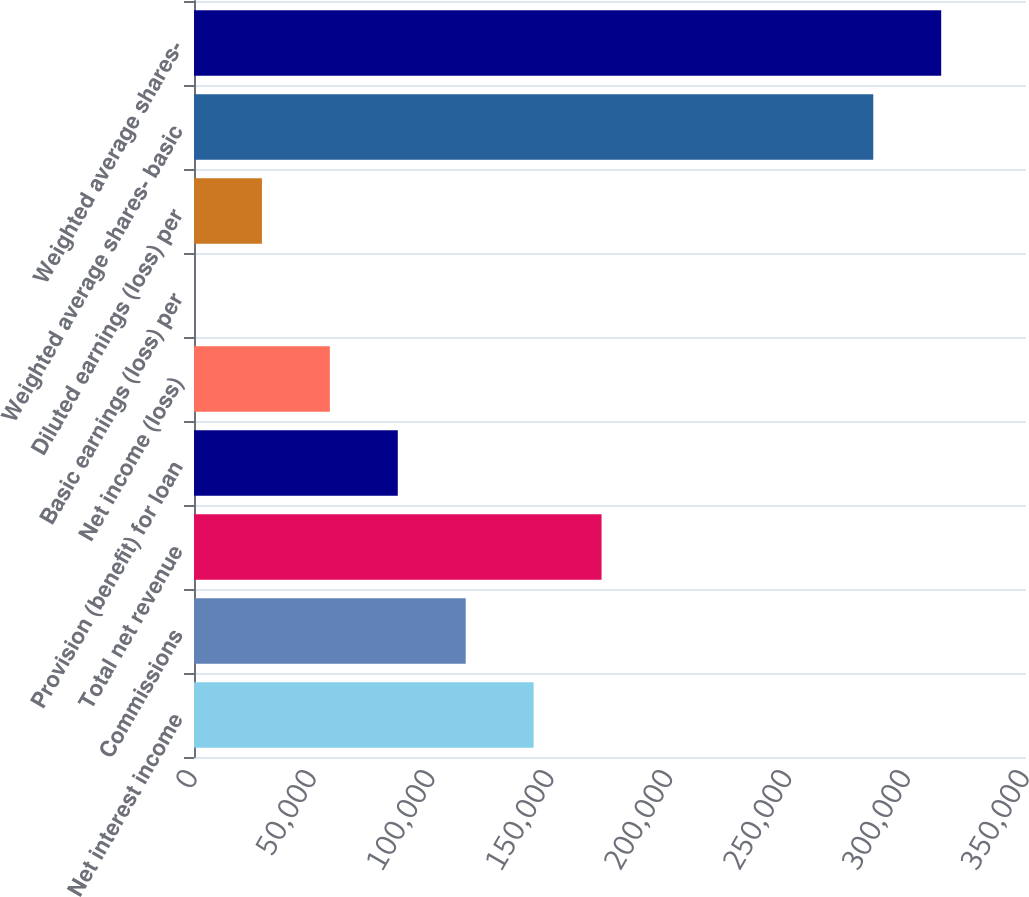Convert chart to OTSL. <chart><loc_0><loc_0><loc_500><loc_500><bar_chart><fcel>Net interest income<fcel>Commissions<fcel>Total net revenue<fcel>Provision (benefit) for loan<fcel>Net income (loss)<fcel>Basic earnings (loss) per<fcel>Diluted earnings (loss) per<fcel>Weighted average shares- basic<fcel>Weighted average shares-<nl><fcel>142874<fcel>114299<fcel>171449<fcel>85724.7<fcel>57149.9<fcel>0.39<fcel>28575.2<fcel>285748<fcel>314323<nl></chart> 